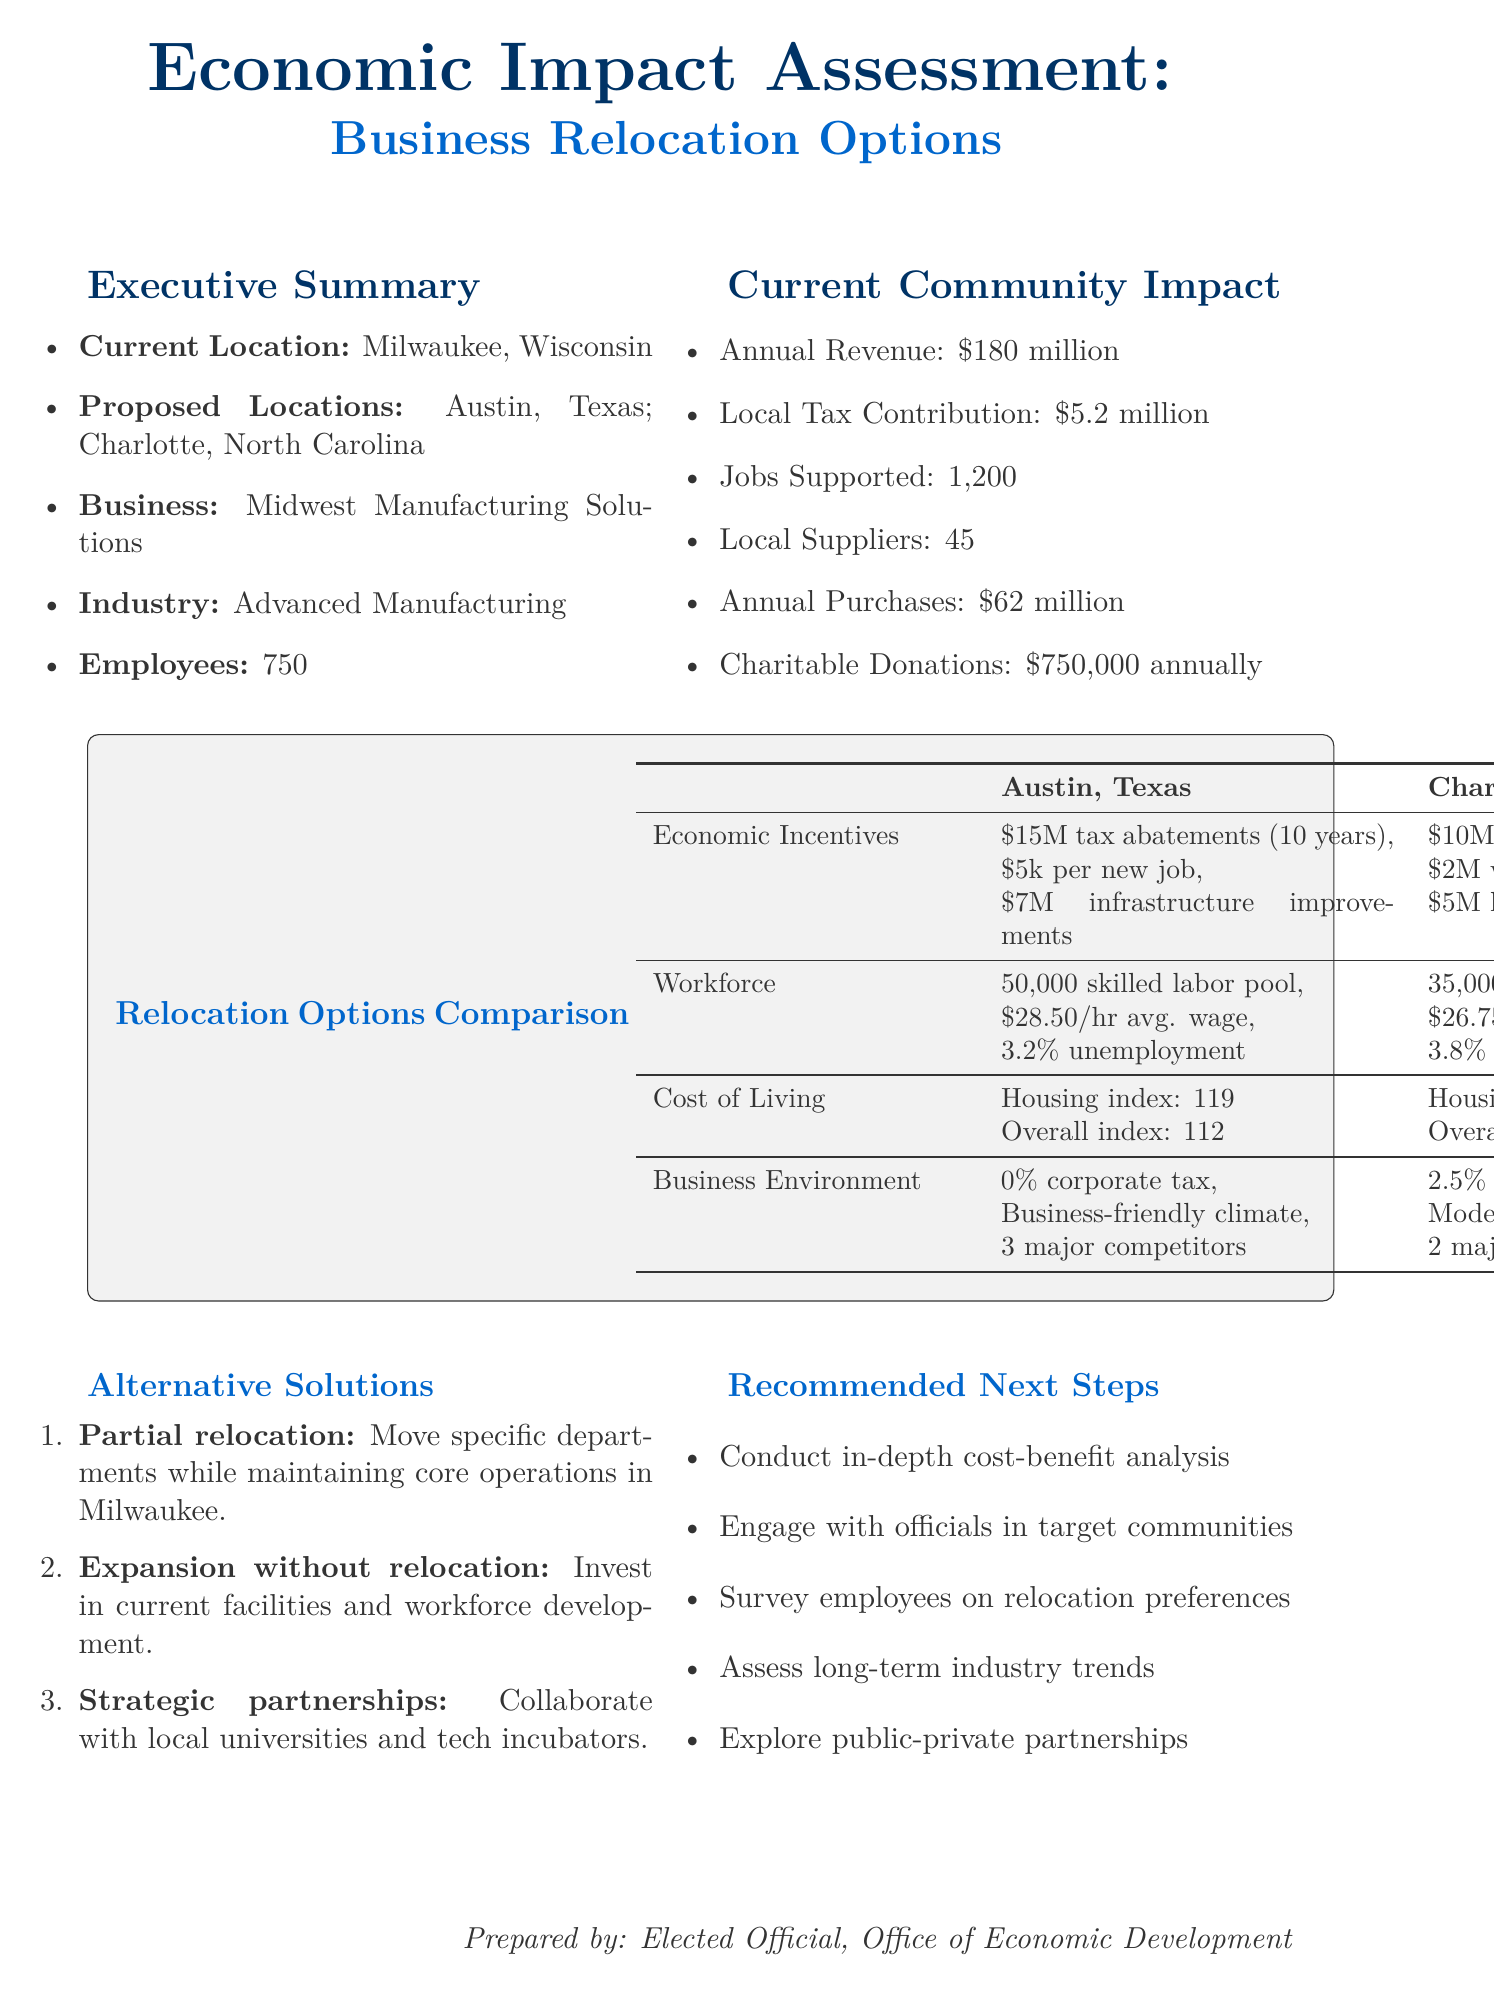What is the current location of the business? The document states that the current location of the business is Milwaukee, Wisconsin.
Answer: Milwaukee, Wisconsin How many employees does Midwest Manufacturing Solutions have? The document indicates that the business has 750 employees.
Answer: 750 What is the annual revenue generated by the business? The document specifies that the annual revenue is $180 million.
Answer: $180 million What are the tax abatements offered by Austin, Texas? The document outlines that Austin offers $15 million in tax abatements over 10 years.
Answer: $15 million over 10 years What is the average wage in Charlotte, North Carolina? The document states that the average wage in Charlotte is $26.75 per hour.
Answer: $26.75 per hour How many major competitors are there in Austin, Texas? The document lists that there are 3 major competitors in Austin.
Answer: 3 What is one potential benefit of partial relocation? The document mentions that one potential benefit of partial relocation is reduced disruption to the current workforce.
Answer: Reduced disruption to current workforce What methodology is used for the economic impact analysis? The document includes Input-Output Model, Cost-Benefit Analysis, and Fiscal Impact Analysis as methodologies.
Answer: Input-Output Model What is a recommended next step after the assessment? The document recommends conducting an in-depth cost-benefit analysis for each option.
Answer: Conduct in-depth cost-benefit analysis 